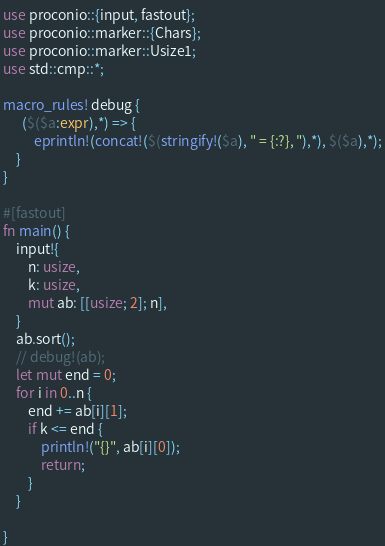Convert code to text. <code><loc_0><loc_0><loc_500><loc_500><_Rust_>use proconio::{input, fastout};
use proconio::marker::{Chars};
use proconio::marker::Usize1;
use std::cmp::*;

macro_rules! debug {
      ($($a:expr),*) => {
          eprintln!(concat!($(stringify!($a), " = {:?}, "),*), $($a),*);
    }
}

#[fastout]
fn main() {
    input!{
        n: usize,
        k: usize,
        mut ab: [[usize; 2]; n],
    }
    ab.sort();
    // debug!(ab);
    let mut end = 0;
    for i in 0..n {
        end += ab[i][1];
        if k <= end {
            println!("{}", ab[i][0]);
            return;
        }
    }

}
</code> 